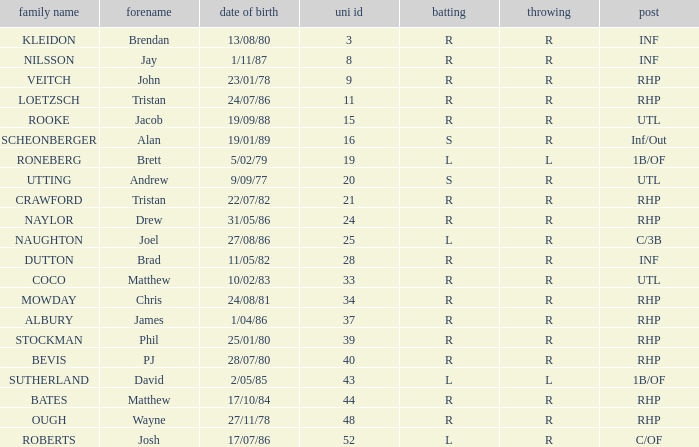Which Surname has Throws of l, and a DOB of 5/02/79? RONEBERG. 